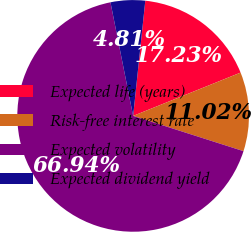Convert chart. <chart><loc_0><loc_0><loc_500><loc_500><pie_chart><fcel>Expected life (years)<fcel>Risk-free interest rate<fcel>Expected volatility<fcel>Expected dividend yield<nl><fcel>17.23%<fcel>11.02%<fcel>66.94%<fcel>4.81%<nl></chart> 